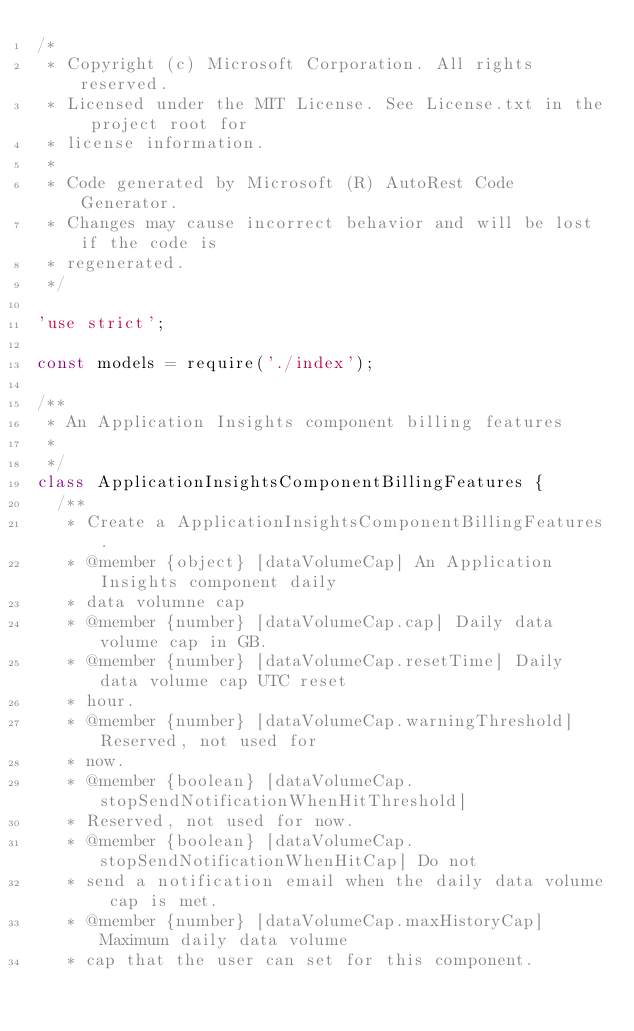<code> <loc_0><loc_0><loc_500><loc_500><_JavaScript_>/*
 * Copyright (c) Microsoft Corporation. All rights reserved.
 * Licensed under the MIT License. See License.txt in the project root for
 * license information.
 *
 * Code generated by Microsoft (R) AutoRest Code Generator.
 * Changes may cause incorrect behavior and will be lost if the code is
 * regenerated.
 */

'use strict';

const models = require('./index');

/**
 * An Application Insights component billing features
 *
 */
class ApplicationInsightsComponentBillingFeatures {
  /**
   * Create a ApplicationInsightsComponentBillingFeatures.
   * @member {object} [dataVolumeCap] An Application Insights component daily
   * data volumne cap
   * @member {number} [dataVolumeCap.cap] Daily data volume cap in GB.
   * @member {number} [dataVolumeCap.resetTime] Daily data volume cap UTC reset
   * hour.
   * @member {number} [dataVolumeCap.warningThreshold] Reserved, not used for
   * now.
   * @member {boolean} [dataVolumeCap.stopSendNotificationWhenHitThreshold]
   * Reserved, not used for now.
   * @member {boolean} [dataVolumeCap.stopSendNotificationWhenHitCap] Do not
   * send a notification email when the daily data volume cap is met.
   * @member {number} [dataVolumeCap.maxHistoryCap] Maximum daily data volume
   * cap that the user can set for this component.</code> 